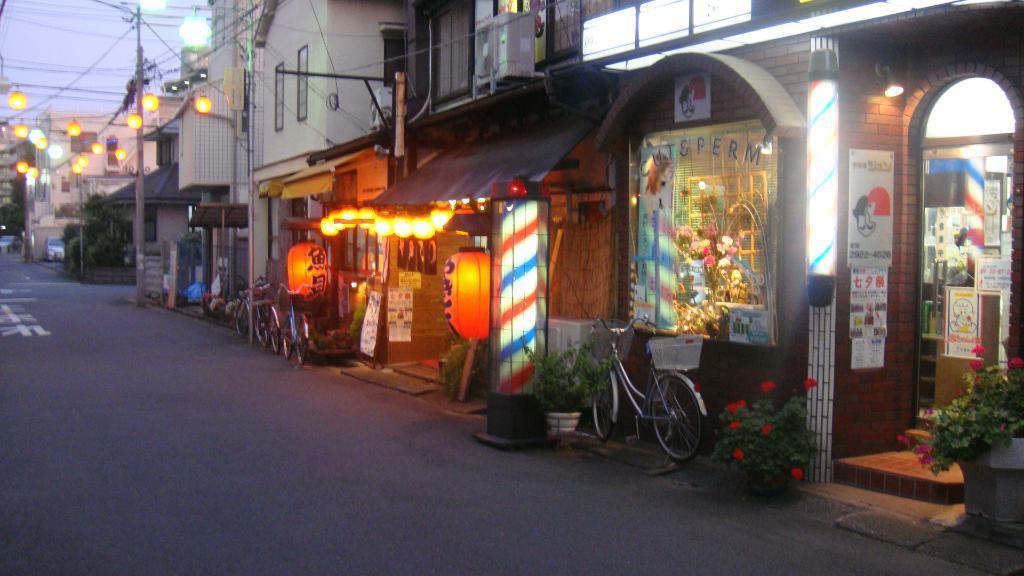How would you summarize this image in a sentence or two? In this image we can see some buildings, plants, bicycles, lights, poles, boards and other objects. In the background of the image there is the sky. At the bottom of the image there is the road. 